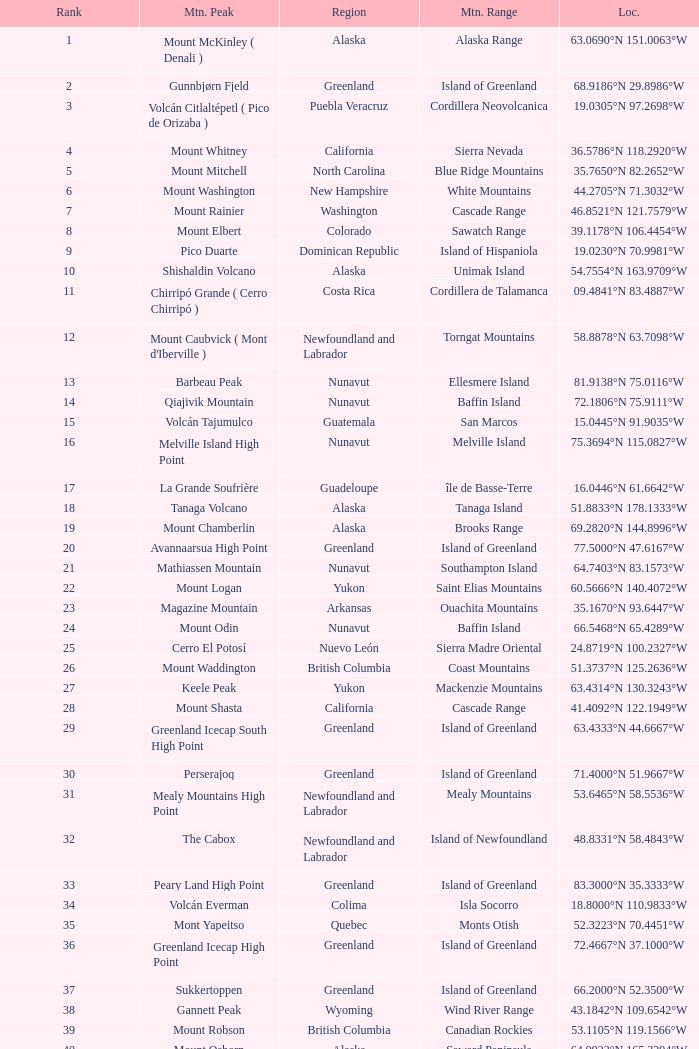Name the Mountain Peak which has a Rank of 62? Cerro Nube ( Quie Yelaag ). 